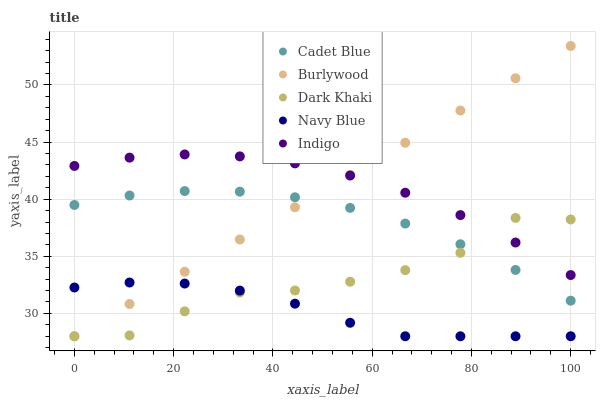Does Navy Blue have the minimum area under the curve?
Answer yes or no. Yes. Does Indigo have the maximum area under the curve?
Answer yes or no. Yes. Does Dark Khaki have the minimum area under the curve?
Answer yes or no. No. Does Dark Khaki have the maximum area under the curve?
Answer yes or no. No. Is Burlywood the smoothest?
Answer yes or no. Yes. Is Dark Khaki the roughest?
Answer yes or no. Yes. Is Cadet Blue the smoothest?
Answer yes or no. No. Is Cadet Blue the roughest?
Answer yes or no. No. Does Burlywood have the lowest value?
Answer yes or no. Yes. Does Cadet Blue have the lowest value?
Answer yes or no. No. Does Burlywood have the highest value?
Answer yes or no. Yes. Does Dark Khaki have the highest value?
Answer yes or no. No. Is Cadet Blue less than Indigo?
Answer yes or no. Yes. Is Indigo greater than Cadet Blue?
Answer yes or no. Yes. Does Dark Khaki intersect Burlywood?
Answer yes or no. Yes. Is Dark Khaki less than Burlywood?
Answer yes or no. No. Is Dark Khaki greater than Burlywood?
Answer yes or no. No. Does Cadet Blue intersect Indigo?
Answer yes or no. No. 